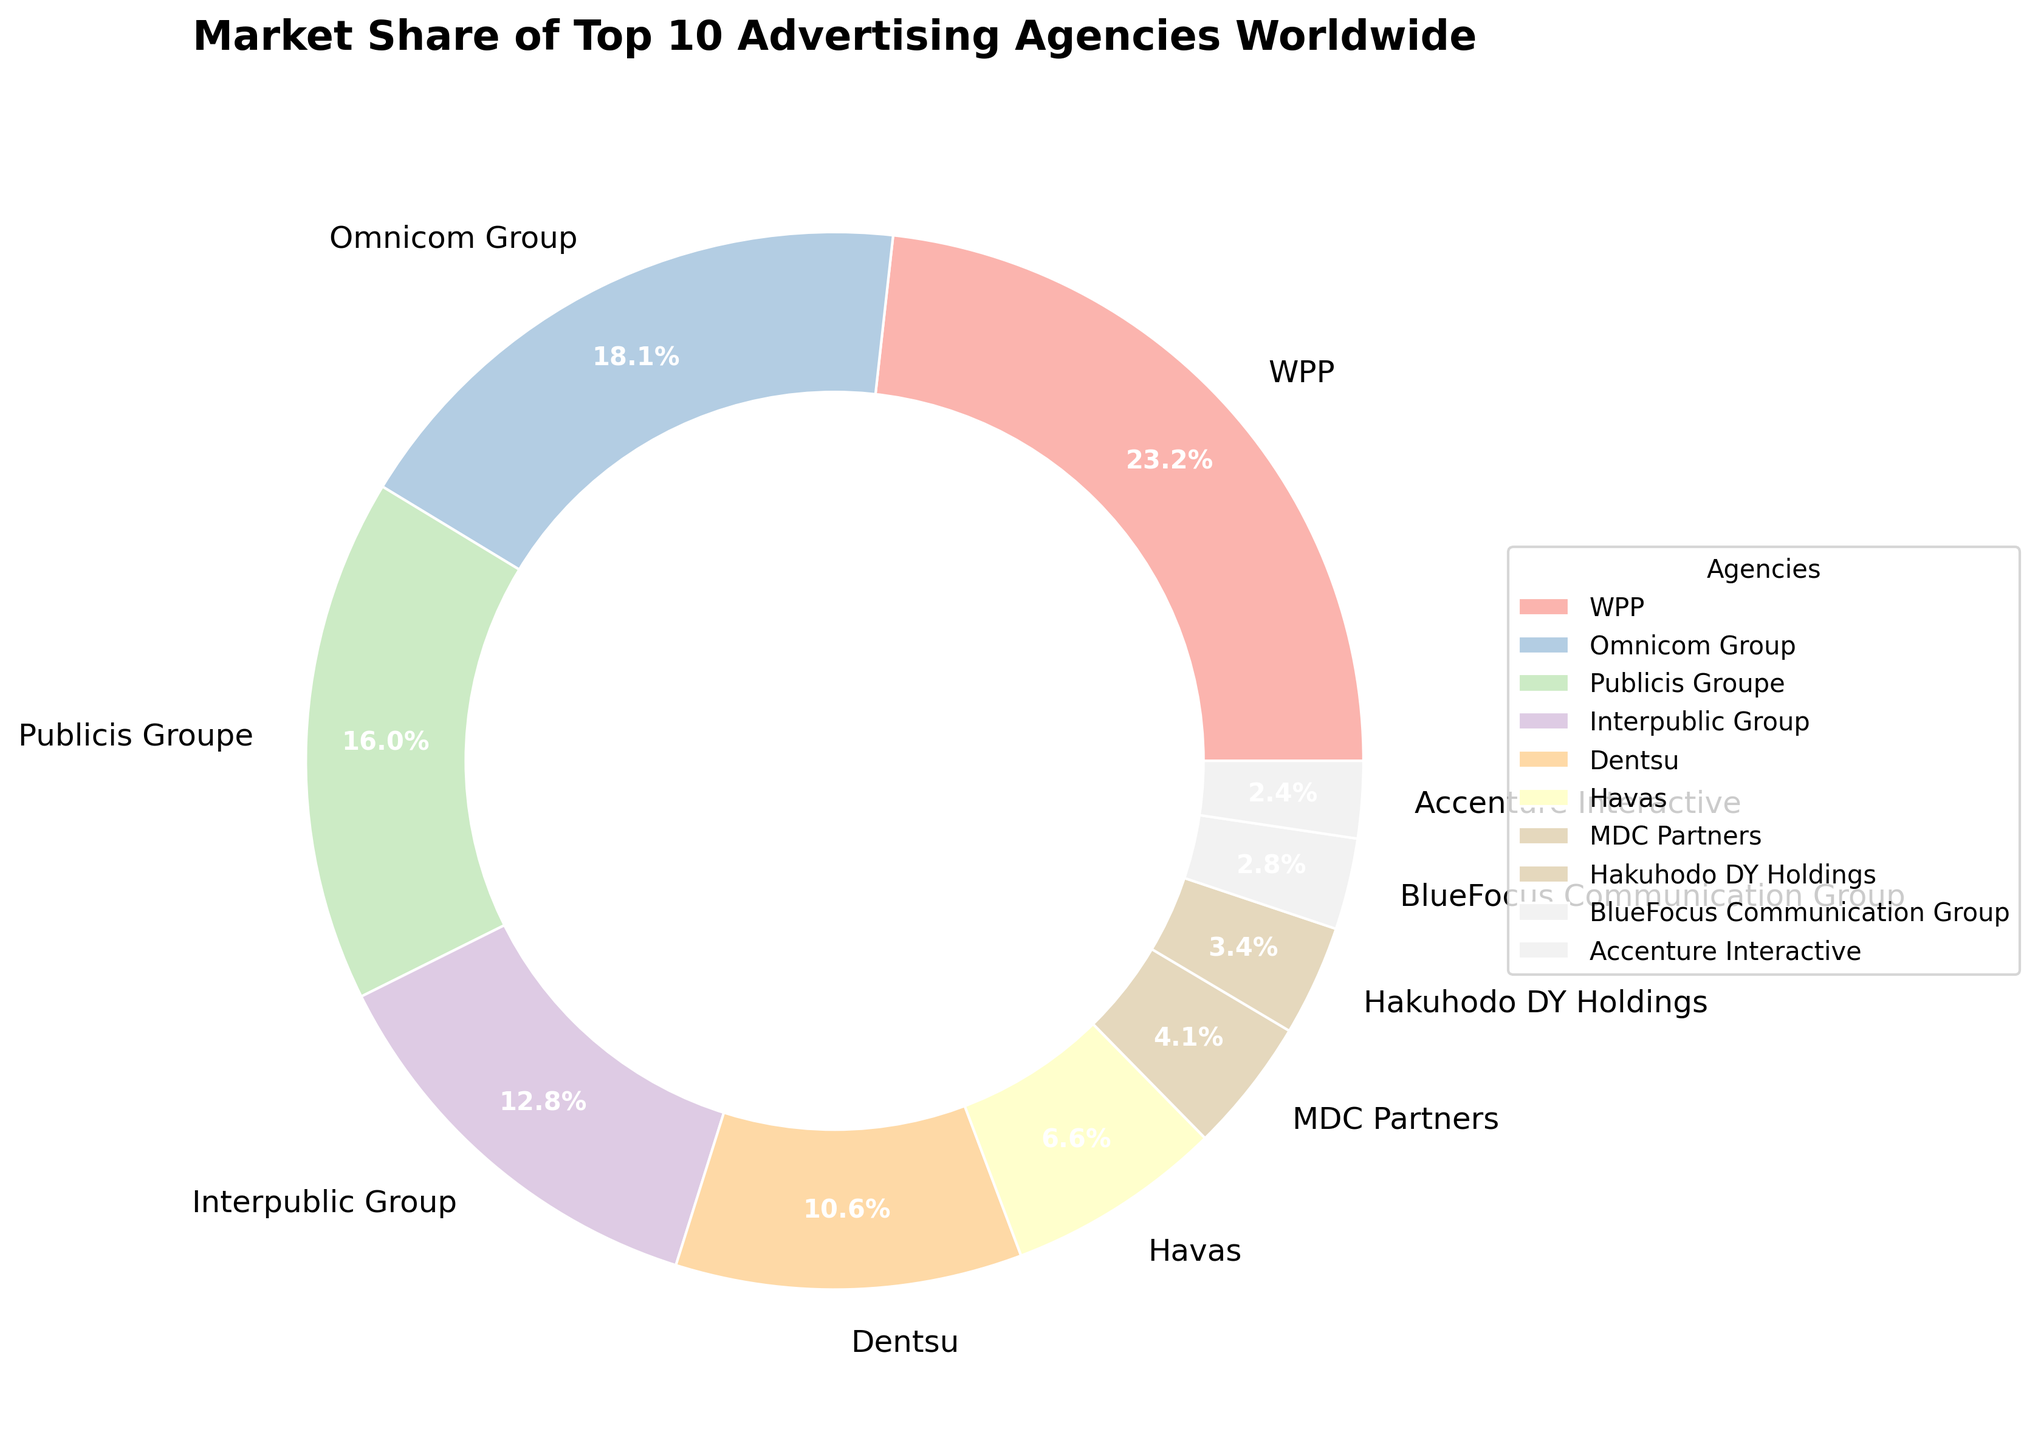What is the market share percentage of WPP? The market share percentage is directly labeled next to the WPP section in the pie chart.
Answer: 15.8% Which agency has the smallest market share, and what is that percentage? By observing the sizes of the slices in the pie chart and the corresponding percentages, Accenture Interactive has the smallest market share.
Answer: Accenture Interactive, 1.6% How much larger is WPP's market share than Omnicom Group's? WPP's market share is 15.8% and Omnicom Group's is 12.3%. Subtract Omnicom Group's percentage from WPP's. 15.8% - 12.3% = 3.5%.
Answer: 3.5% What is the total market share of the top three agencies? The market shares of the top three agencies are WPP (15.8%), Omnicom Group (12.3%), and Publicis Groupe (10.9%). Sum these values: 15.8 + 12.3 + 10.9 = 39.0%.
Answer: 39.0% Which agency's slice is directly next to Dentsu in the pie chart, and what is its market share percentage? By visually inspecting the chart, the slice for Interpublic Group shares a border with the slice for Dentsu. Dentsu has a market share of 7.2% and Interpublic Group has a market share of 8.7%.
Answer: Interpublic Group, 8.7% What is the combined market share of Dentsu and MDC Partners, and how does it compare to Omnicom Group’s market share? Dentsu has a market share of 7.2% and MDC Partners has 2.8%. Their combined share is 7.2% + 2.8% = 10.0%. Omnicom Group has a market share of 12.3%. Comparing the two, Omnicom Group's share is larger by 2.3%.
Answer: 10.0%, Smaller Which agency has an approximately equal market share to the combined market share of Havas and Hakuhodo DY Holdings? The market share of Havas is 4.5% and Hakuhodo DY Holdings is 2.3%. Their combined share is 4.5% + 2.3% = 6.8%. Dentsu has a market share of 7.2%, which is the closest to 6.8%.
Answer: Dentsu, 7.2% Which agency's market share is visually represented by the largest slice, and how much larger is it than the slice representing Interpublic Group? The largest slice represents WPP with 15.8%. The slice representing Interpublic Group is 8.7%. The difference is 15.8% - 8.7% = 7.1%.
Answer: WPP, 7.1% 